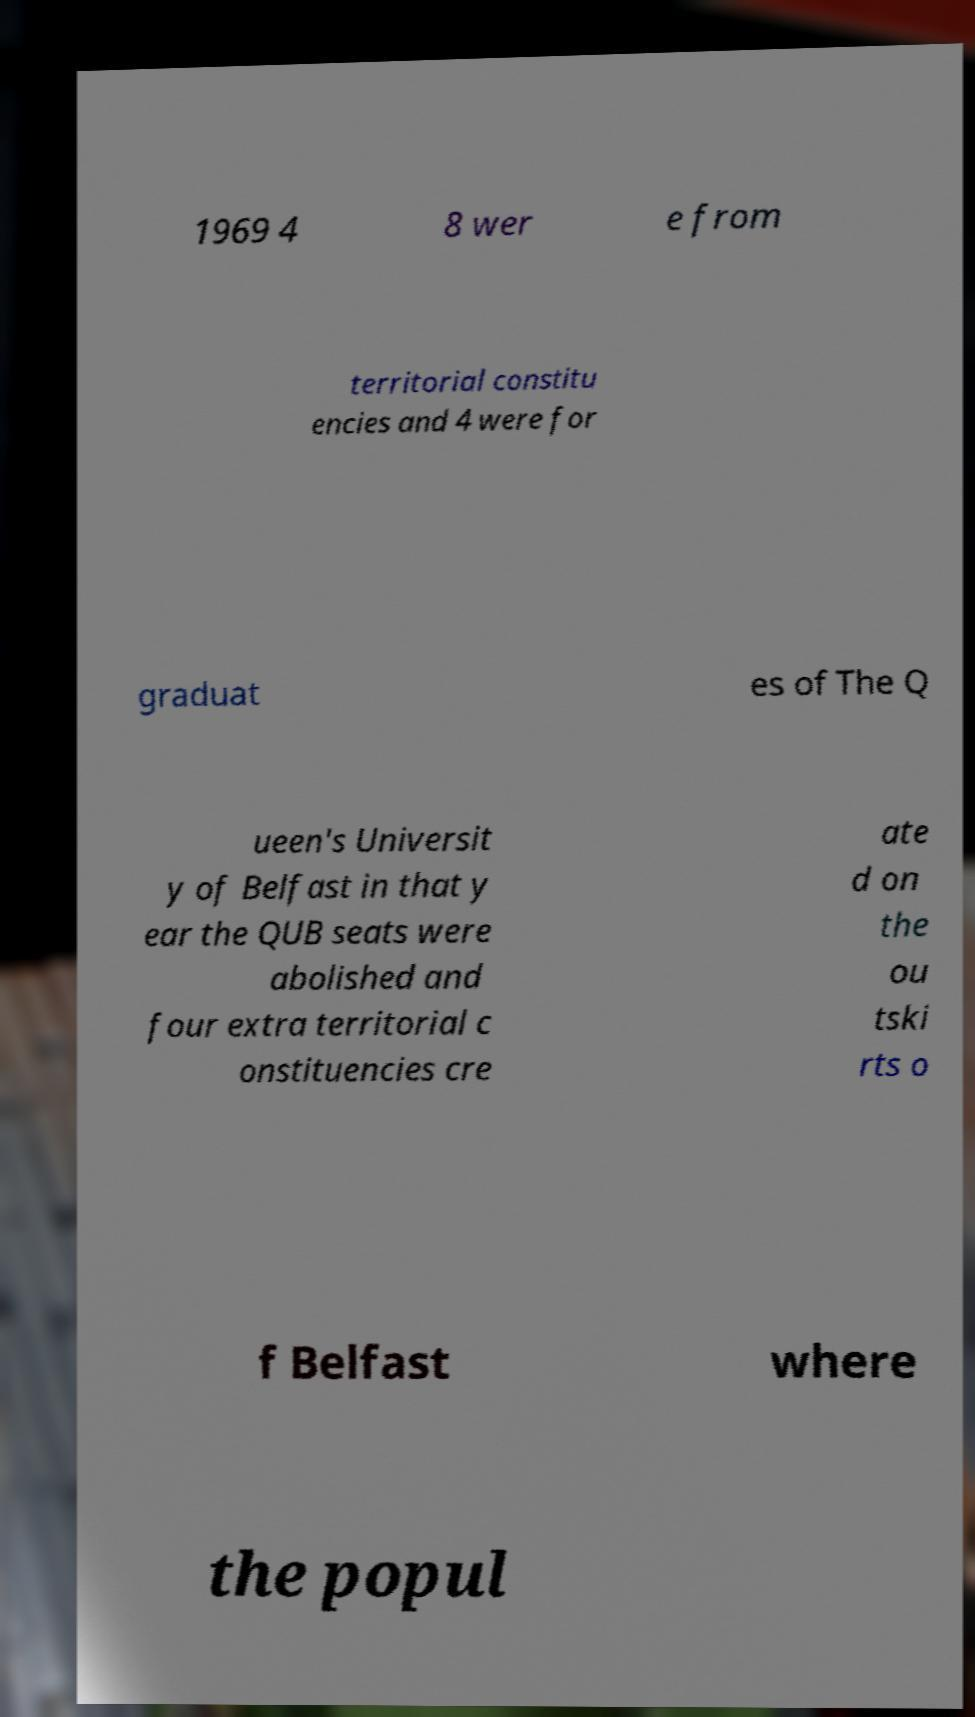What messages or text are displayed in this image? I need them in a readable, typed format. 1969 4 8 wer e from territorial constitu encies and 4 were for graduat es of The Q ueen's Universit y of Belfast in that y ear the QUB seats were abolished and four extra territorial c onstituencies cre ate d on the ou tski rts o f Belfast where the popul 